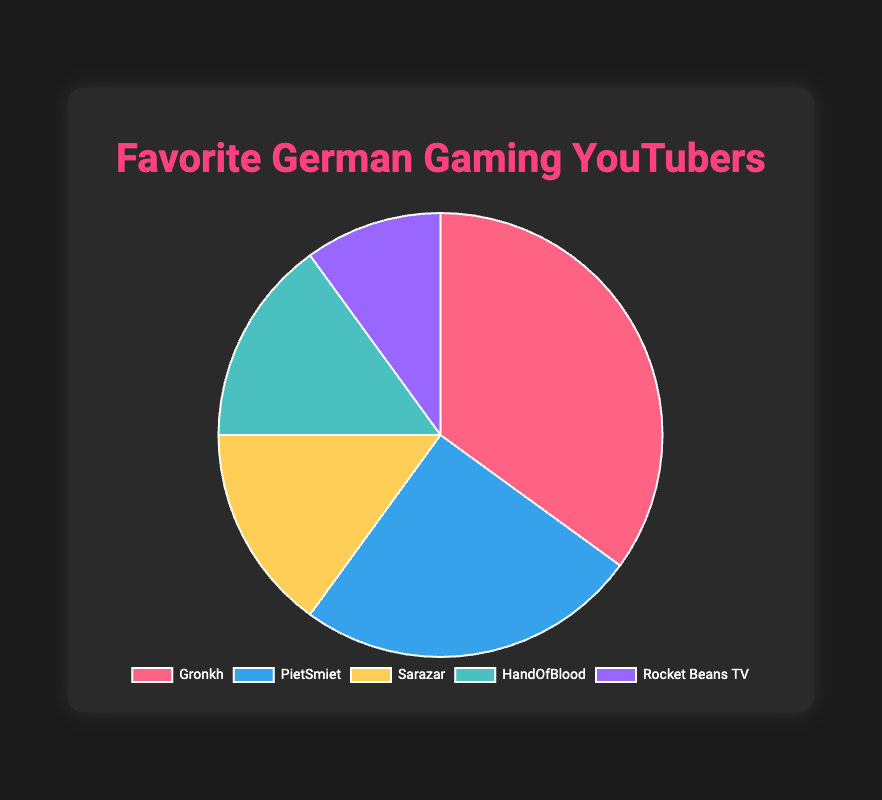Which YouTuber has the highest subscriber count percentage? The YouTuber with the highest subscriber count percentage is identified by the largest section in the pie chart. In this case, Gronkh has the largest section.
Answer: Gronkh What is the difference in subscriber count percentage between Gronkh and Rocket Beans TV? The difference is calculated by subtracting Rocket Beans TV's percentage from Gronkh's percentage: 35% - 10% = 25%.
Answer: 25% Which YouTubers have the same subscriber count percentage? By looking at the pie chart, identify sections of the same size. Sarazar and HandOfBlood both have 15%.
Answer: Sarazar and HandOfBlood What is the total subscriber count percentage for PietSmiet, Sarazar, and HandOfBlood combined? Add the percentages of these YouTubers: 25% (PietSmiet) + 15% (Sarazar) + 15% (HandOfBlood) = 55%.
Answer: 55% How much larger is Gronkh's subscriber count percentage compared to PietSmiet's? Subtract PietSmiet's percentage from Gronkh's percentage: 35% - 25% = 10%.
Answer: 10% Which YouTuber is represented by the yellow section in the pie chart? Identify the color of each section. The yellow section represents Sarazar.
Answer: Sarazar If the total subscriber count percentage of all YouTubers combined is 100%, what is the average subscriber count percentage? Divide the total percentage (100%) by the number of YouTubers (5): 100% / 5 = 20%.
Answer: 20% What is the combined subscriber count percentage of YouTubers other than Gronkh? Subtract Gronkh's percentage from 100%: 100% - 35% = 65%.
Answer: 65% Is the subscriber count percentage of HandOfBlood greater than that of Rocket Beans TV? Compare the percentages directly: HandOfBlood has 15%, while Rocket Beans TV has 10%, so 15% > 10%.
Answer: Yes If Gronkh gained an additional 5% in subscriber count, what would his new percentage be? Add 5% to the current percentage: 35% + 5% = 40%.
Answer: 40% 